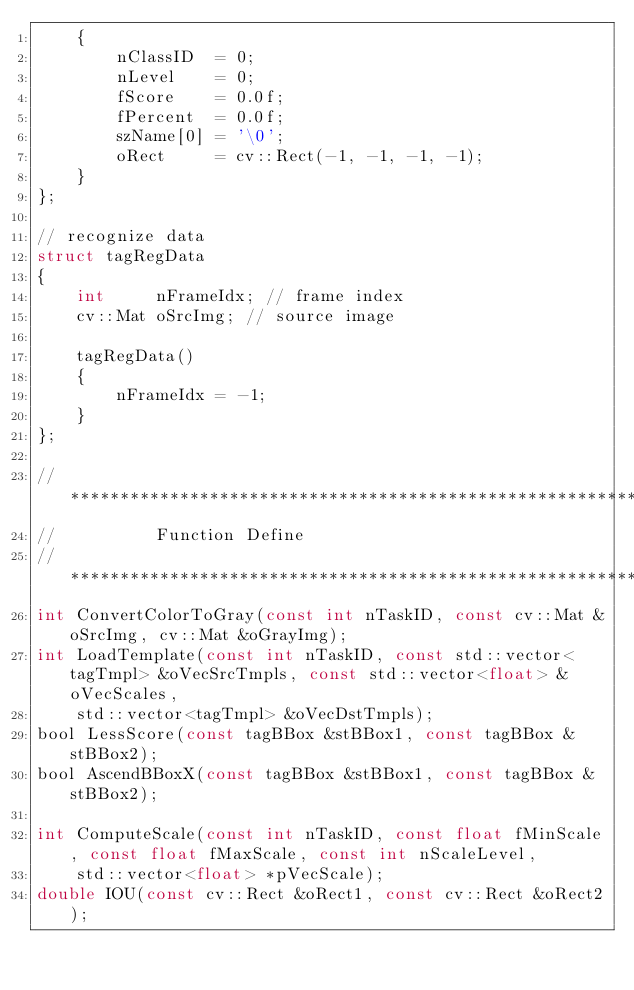<code> <loc_0><loc_0><loc_500><loc_500><_C_>    {
        nClassID  = 0;
        nLevel    = 0;
        fScore    = 0.0f;
        fPercent  = 0.0f;
        szName[0] = '\0';
        oRect     = cv::Rect(-1, -1, -1, -1);
    }
};

// recognize data
struct tagRegData
{
    int     nFrameIdx; // frame index
    cv::Mat oSrcImg; // source image

    tagRegData()
    {
        nFrameIdx = -1;
    }
};

// **************************************************************************************
//          Function Define
// **************************************************************************************
int ConvertColorToGray(const int nTaskID, const cv::Mat &oSrcImg, cv::Mat &oGrayImg);
int LoadTemplate(const int nTaskID, const std::vector<tagTmpl> &oVecSrcTmpls, const std::vector<float> &oVecScales,
    std::vector<tagTmpl> &oVecDstTmpls);
bool LessScore(const tagBBox &stBBox1, const tagBBox &stBBox2);
bool AscendBBoxX(const tagBBox &stBBox1, const tagBBox &stBBox2);

int ComputeScale(const int nTaskID, const float fMinScale, const float fMaxScale, const int nScaleLevel,
    std::vector<float> *pVecScale);
double IOU(const cv::Rect &oRect1, const cv::Rect &oRect2);</code> 